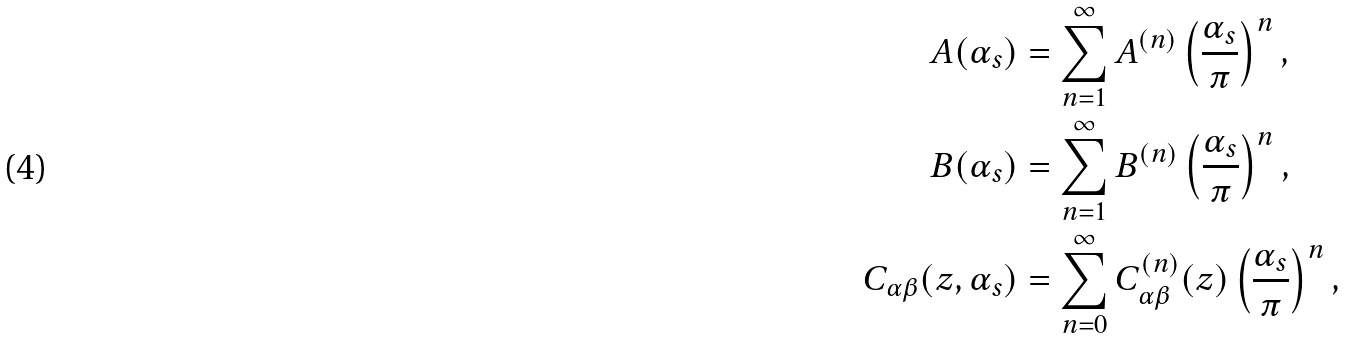Convert formula to latex. <formula><loc_0><loc_0><loc_500><loc_500>A ( \alpha _ { s } ) & = \sum _ { n = 1 } ^ { \infty } A ^ { ( n ) } \left ( \frac { \alpha _ { s } } { \pi } \right ) ^ { n } , \\ B ( \alpha _ { s } ) & = \sum _ { n = 1 } ^ { \infty } B ^ { ( n ) } \left ( \frac { \alpha _ { s } } { \pi } \right ) ^ { n } , \\ C _ { \alpha \beta } ( z , \alpha _ { s } ) & = \sum _ { n = 0 } ^ { \infty } C _ { \alpha \beta } ^ { ( n ) } ( z ) \left ( \frac { \alpha _ { s } } { \pi } \right ) ^ { n } ,</formula> 